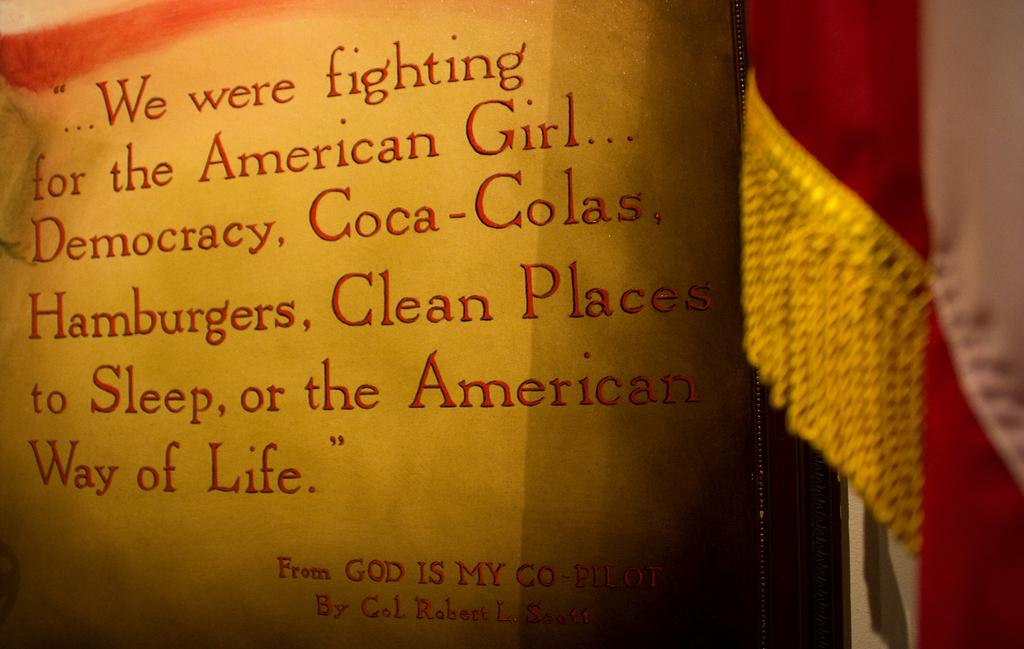Provide a one-sentence caption for the provided image. A quote from God Is My Co-Pilot explains what the author was fighting for. 